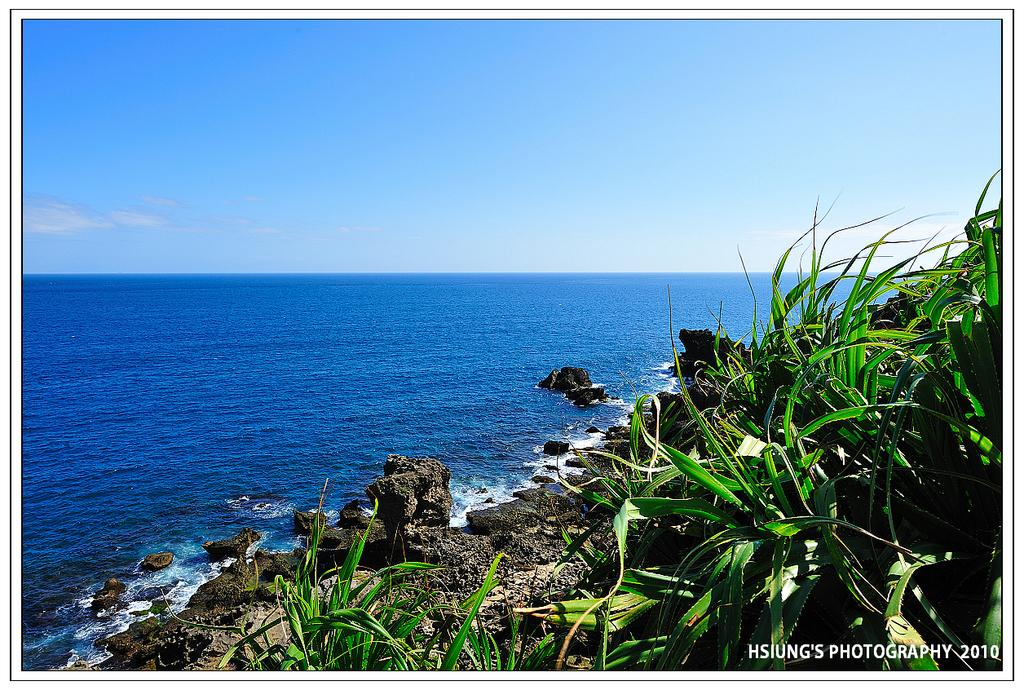What is the main feature in the foreground of the image? There is a sea in the foreground of the image. What else can be seen in the foreground of the image? There are rocks and plants in the foreground of the image. What is visible in the background of the image? The sky is visible in the image. What type of coach can be seen in the image? There is no coach present in the image. Is there a frog celebrating its birthday in the image? There is no frog or birthday celebration depicted in the image. 